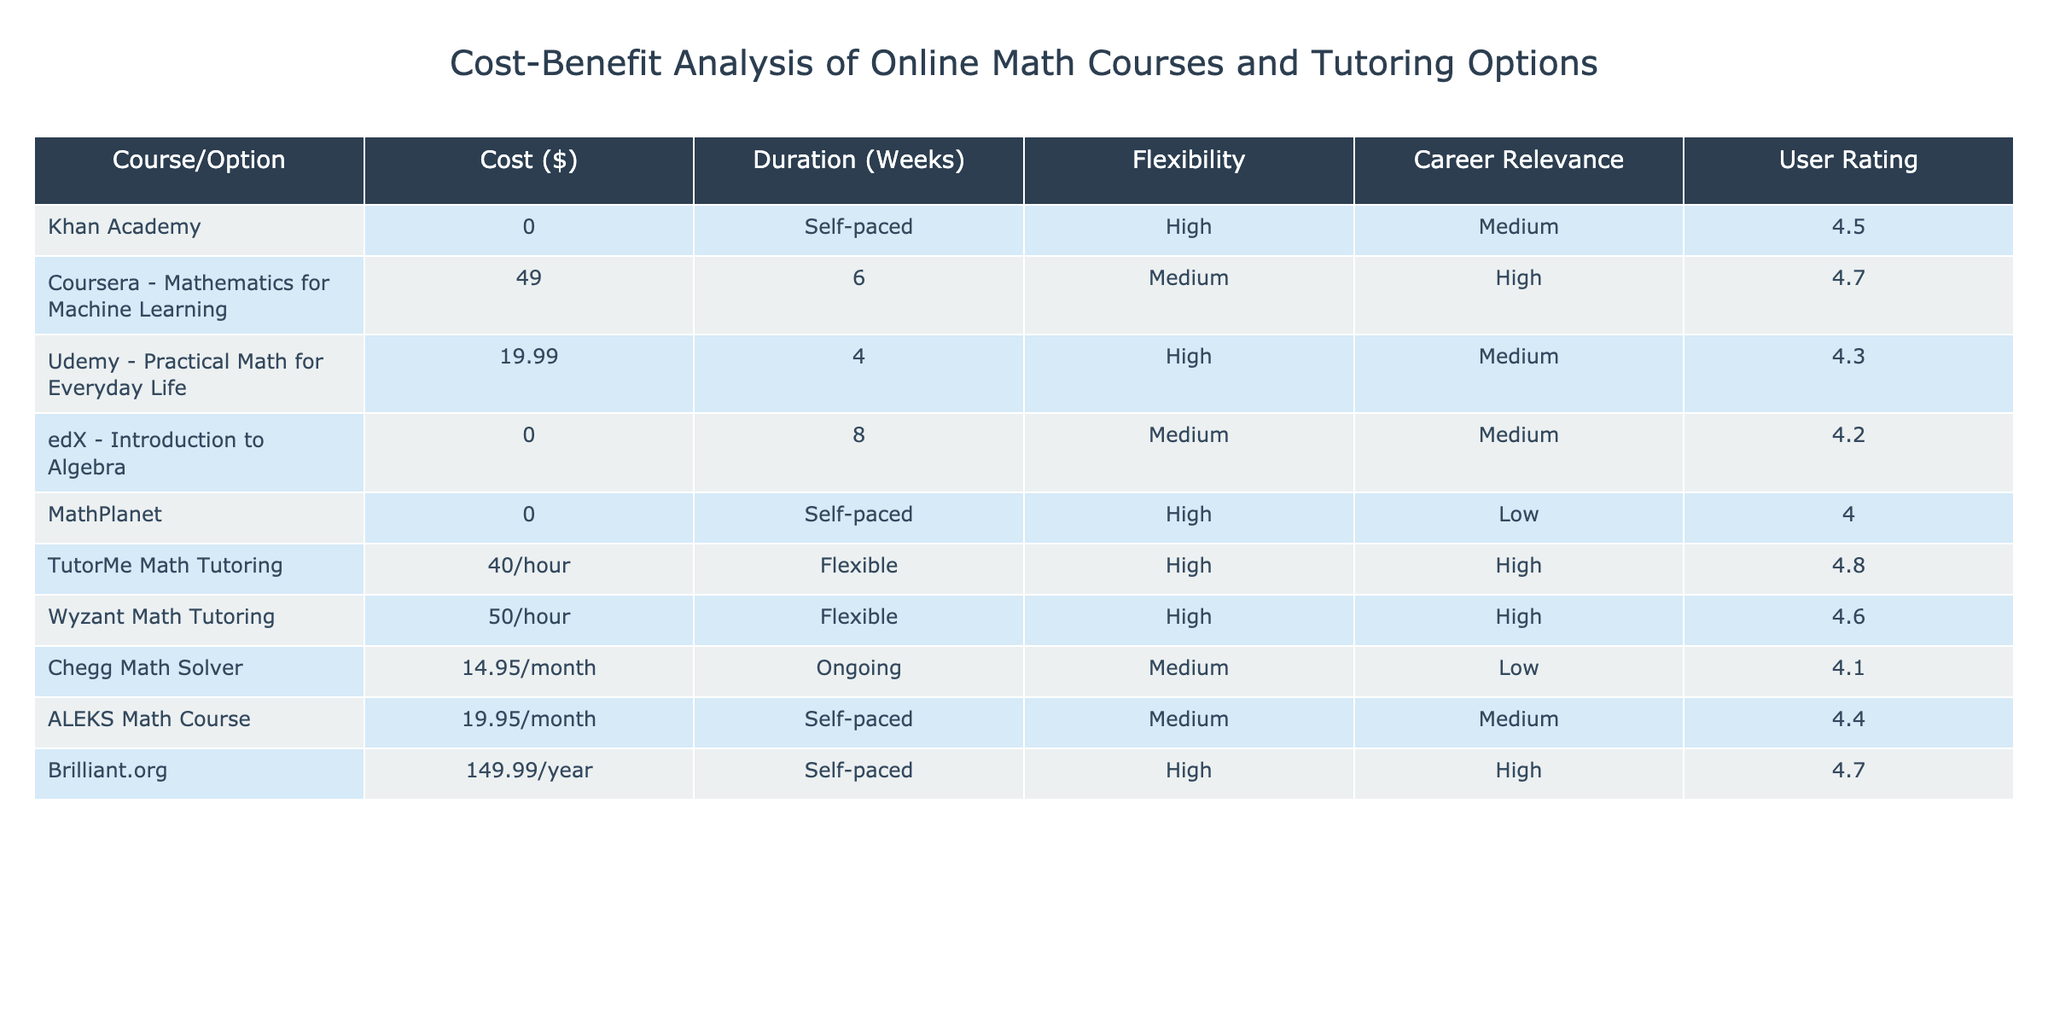What is the cost of the Coursera Mathematics for Machine Learning course? The table lists the cost for the Coursera Mathematics for Machine Learning course as $49.
Answer: $49 Which online tutoring option has the highest user rating? The highest user rating is found in the TutorMe Math Tutoring option, which has a rating of 4.8.
Answer: TutorMe Math Tutoring How much does it cost per month for the Chegg Math Solver? The cost for the Chegg Math Solver is $14.95 per month, as indicated in the table.
Answer: $14.95 What is the average cost of the options listed in the table? The options with specific costs add up to $49 + $19.99 + $19.95 + $40 + $50 + $14.95 + $149.99, totaling $344.88 for 7 options. Thus, the average cost is $344.88 / 7 ≈ $49.26.
Answer: Approximately $49.26 Does Brilliant.org have higher career relevance than MathPlanet? Based on the table, Brilliant.org has a career relevance rated as "High" while MathPlanet has "Low."
Answer: Yes What is the total duration in weeks for the courses which have a fixed duration instead of being self-paced? The durations for fixed duration courses are 6 weeks for Coursera, 4 weeks for Udemy, and 8 weeks for edX, totaling 6 + 4 + 8 = 18 weeks.
Answer: 18 weeks Which course option offers the most flexibility? The courses that offer the most flexibility are Khan Academy, MathPlanet, and the tutor options (TutorMe and Wyzant), but in terms of structured courses, Khan Academy and MathPlanet provide the highest flexibility as self-paced.
Answer: Khan Academy and MathPlanet If I spend $40 each time on TutorMe Math Tutoring, how much will I spend for 5 sessions? The total spending for 5 sessions at $40 each would be calculated as 5 x $40, which equals $200.
Answer: $200 Are any of the options provided free of charge? Yes, Khan Academy and edX's Introduction to Algebra courses are free of charge according to the table.
Answer: Yes Which option has the longest duration in weeks? The longest duration listed is for edX's Introduction to Algebra at 8 weeks.
Answer: 8 weeks 